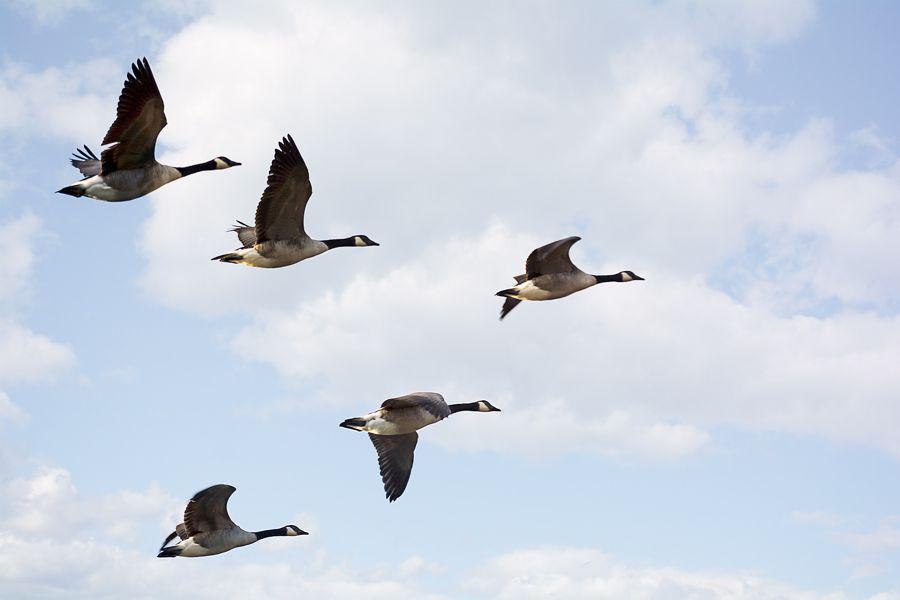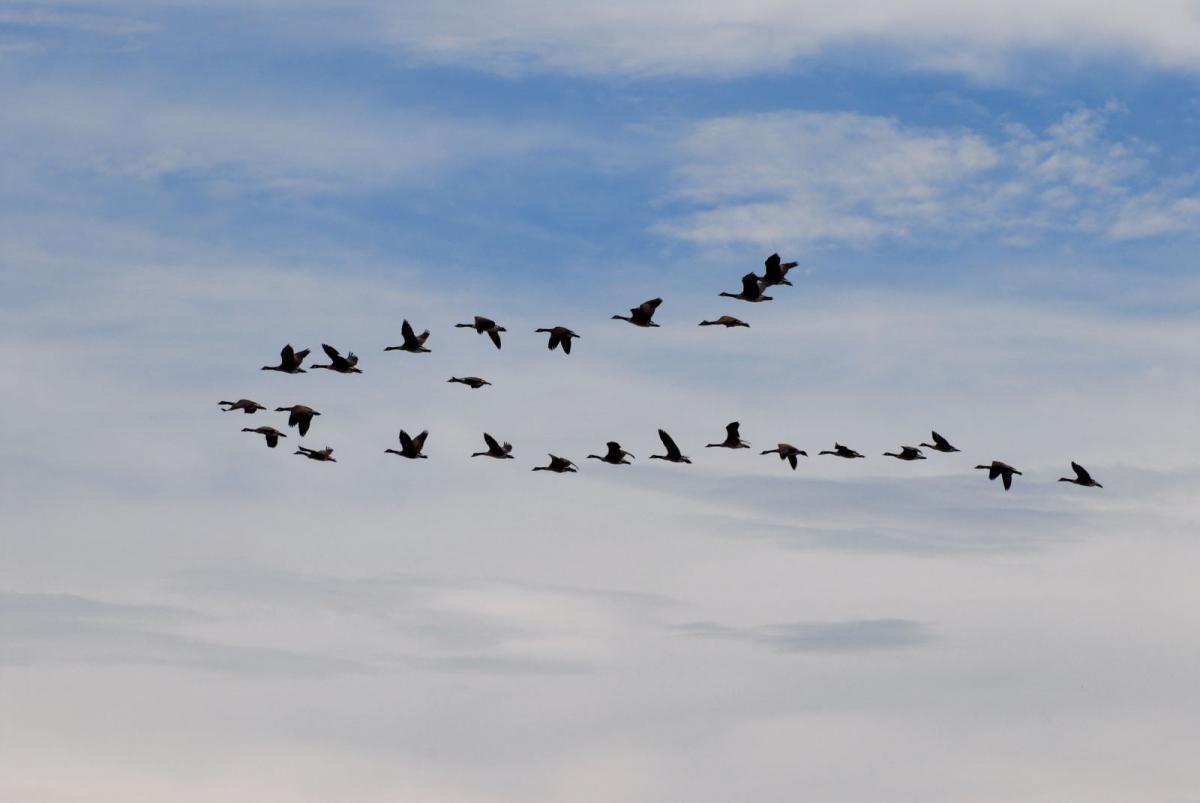The first image is the image on the left, the second image is the image on the right. For the images shown, is this caption "The right image contains more birds than the left image." true? Answer yes or no. Yes. 